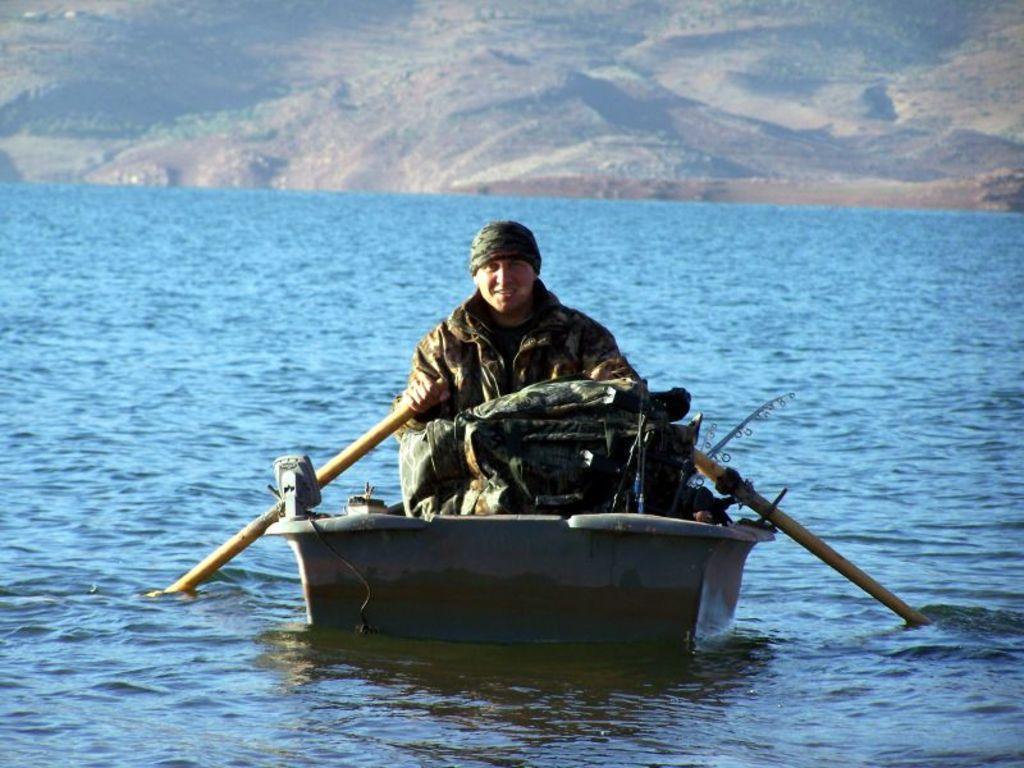Please provide a concise description of this image. In this picture I can see a boat in the water and I can see a man seated in the boat and holding couple of pedals in his hands and looks like a bag and front and I can see a fishing stick in the back and he wore a cap on his head. 